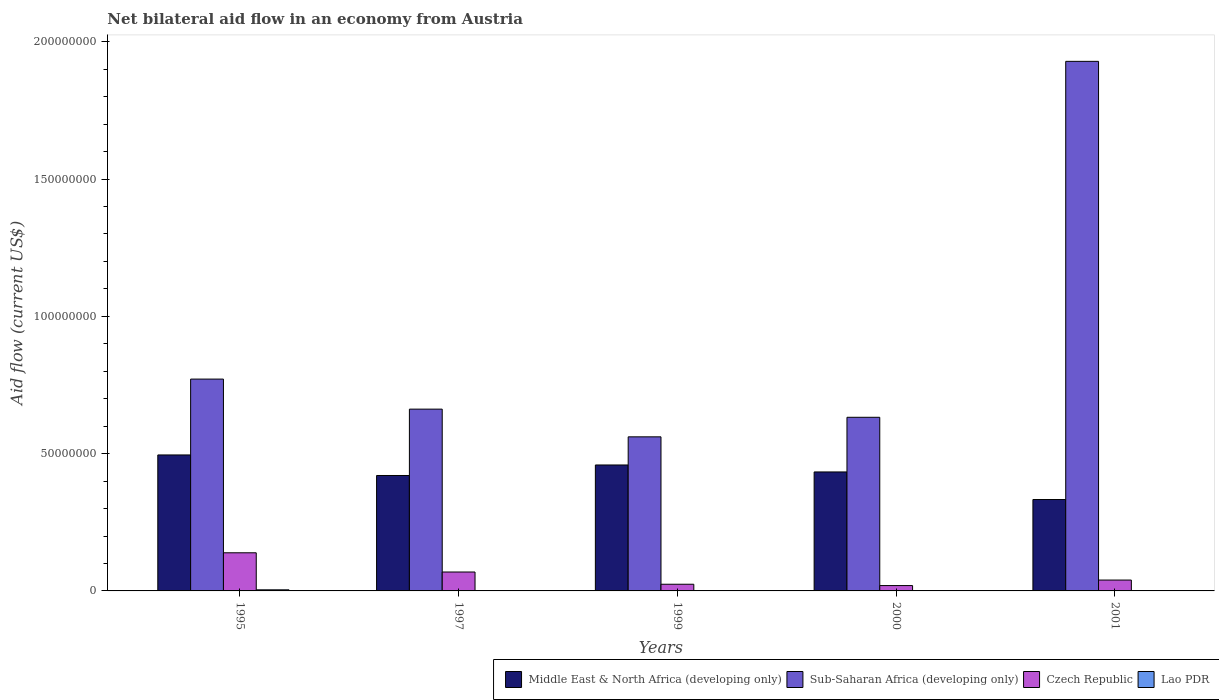How many different coloured bars are there?
Ensure brevity in your answer.  4. How many groups of bars are there?
Ensure brevity in your answer.  5. Are the number of bars per tick equal to the number of legend labels?
Provide a short and direct response. Yes. Are the number of bars on each tick of the X-axis equal?
Offer a terse response. Yes. What is the label of the 2nd group of bars from the left?
Offer a terse response. 1997. In how many cases, is the number of bars for a given year not equal to the number of legend labels?
Make the answer very short. 0. What is the net bilateral aid flow in Lao PDR in 1995?
Offer a terse response. 4.00e+05. Across all years, what is the maximum net bilateral aid flow in Lao PDR?
Offer a terse response. 4.00e+05. Across all years, what is the minimum net bilateral aid flow in Czech Republic?
Provide a succinct answer. 1.95e+06. In which year was the net bilateral aid flow in Czech Republic maximum?
Ensure brevity in your answer.  1995. In which year was the net bilateral aid flow in Czech Republic minimum?
Provide a short and direct response. 2000. What is the total net bilateral aid flow in Sub-Saharan Africa (developing only) in the graph?
Ensure brevity in your answer.  4.56e+08. What is the difference between the net bilateral aid flow in Czech Republic in 1995 and that in 1999?
Your response must be concise. 1.15e+07. What is the difference between the net bilateral aid flow in Middle East & North Africa (developing only) in 2000 and the net bilateral aid flow in Czech Republic in 1997?
Provide a succinct answer. 3.64e+07. What is the average net bilateral aid flow in Czech Republic per year?
Provide a short and direct response. 5.82e+06. In the year 1999, what is the difference between the net bilateral aid flow in Sub-Saharan Africa (developing only) and net bilateral aid flow in Middle East & North Africa (developing only)?
Provide a short and direct response. 1.02e+07. In how many years, is the net bilateral aid flow in Middle East & North Africa (developing only) greater than 130000000 US$?
Offer a terse response. 0. Is the net bilateral aid flow in Sub-Saharan Africa (developing only) in 1997 less than that in 1999?
Provide a short and direct response. No. What is the difference between the highest and the lowest net bilateral aid flow in Middle East & North Africa (developing only)?
Your response must be concise. 1.62e+07. In how many years, is the net bilateral aid flow in Czech Republic greater than the average net bilateral aid flow in Czech Republic taken over all years?
Keep it short and to the point. 2. Is the sum of the net bilateral aid flow in Lao PDR in 1999 and 2001 greater than the maximum net bilateral aid flow in Middle East & North Africa (developing only) across all years?
Provide a succinct answer. No. Is it the case that in every year, the sum of the net bilateral aid flow in Lao PDR and net bilateral aid flow in Sub-Saharan Africa (developing only) is greater than the sum of net bilateral aid flow in Middle East & North Africa (developing only) and net bilateral aid flow in Czech Republic?
Your answer should be compact. No. What does the 2nd bar from the left in 1995 represents?
Provide a short and direct response. Sub-Saharan Africa (developing only). What does the 4th bar from the right in 1997 represents?
Make the answer very short. Middle East & North Africa (developing only). Is it the case that in every year, the sum of the net bilateral aid flow in Lao PDR and net bilateral aid flow in Czech Republic is greater than the net bilateral aid flow in Middle East & North Africa (developing only)?
Give a very brief answer. No. Are all the bars in the graph horizontal?
Offer a very short reply. No. How many years are there in the graph?
Offer a very short reply. 5. What is the difference between two consecutive major ticks on the Y-axis?
Your answer should be compact. 5.00e+07. Are the values on the major ticks of Y-axis written in scientific E-notation?
Your response must be concise. No. Does the graph contain any zero values?
Your answer should be very brief. No. Does the graph contain grids?
Make the answer very short. No. Where does the legend appear in the graph?
Provide a succinct answer. Bottom right. How are the legend labels stacked?
Offer a terse response. Horizontal. What is the title of the graph?
Provide a succinct answer. Net bilateral aid flow in an economy from Austria. What is the label or title of the X-axis?
Ensure brevity in your answer.  Years. What is the label or title of the Y-axis?
Provide a succinct answer. Aid flow (current US$). What is the Aid flow (current US$) of Middle East & North Africa (developing only) in 1995?
Provide a short and direct response. 4.95e+07. What is the Aid flow (current US$) of Sub-Saharan Africa (developing only) in 1995?
Make the answer very short. 7.72e+07. What is the Aid flow (current US$) in Czech Republic in 1995?
Offer a terse response. 1.39e+07. What is the Aid flow (current US$) of Middle East & North Africa (developing only) in 1997?
Give a very brief answer. 4.20e+07. What is the Aid flow (current US$) in Sub-Saharan Africa (developing only) in 1997?
Ensure brevity in your answer.  6.62e+07. What is the Aid flow (current US$) of Czech Republic in 1997?
Keep it short and to the point. 6.89e+06. What is the Aid flow (current US$) in Lao PDR in 1997?
Make the answer very short. 3.00e+04. What is the Aid flow (current US$) of Middle East & North Africa (developing only) in 1999?
Offer a very short reply. 4.59e+07. What is the Aid flow (current US$) in Sub-Saharan Africa (developing only) in 1999?
Offer a very short reply. 5.61e+07. What is the Aid flow (current US$) of Czech Republic in 1999?
Keep it short and to the point. 2.43e+06. What is the Aid flow (current US$) in Middle East & North Africa (developing only) in 2000?
Your answer should be compact. 4.33e+07. What is the Aid flow (current US$) in Sub-Saharan Africa (developing only) in 2000?
Make the answer very short. 6.32e+07. What is the Aid flow (current US$) in Czech Republic in 2000?
Offer a terse response. 1.95e+06. What is the Aid flow (current US$) of Middle East & North Africa (developing only) in 2001?
Ensure brevity in your answer.  3.33e+07. What is the Aid flow (current US$) of Sub-Saharan Africa (developing only) in 2001?
Give a very brief answer. 1.93e+08. What is the Aid flow (current US$) in Czech Republic in 2001?
Provide a short and direct response. 3.96e+06. What is the Aid flow (current US$) in Lao PDR in 2001?
Provide a short and direct response. 4.00e+04. Across all years, what is the maximum Aid flow (current US$) in Middle East & North Africa (developing only)?
Your response must be concise. 4.95e+07. Across all years, what is the maximum Aid flow (current US$) in Sub-Saharan Africa (developing only)?
Provide a succinct answer. 1.93e+08. Across all years, what is the maximum Aid flow (current US$) of Czech Republic?
Offer a very short reply. 1.39e+07. Across all years, what is the minimum Aid flow (current US$) in Middle East & North Africa (developing only)?
Ensure brevity in your answer.  3.33e+07. Across all years, what is the minimum Aid flow (current US$) of Sub-Saharan Africa (developing only)?
Your answer should be compact. 5.61e+07. Across all years, what is the minimum Aid flow (current US$) in Czech Republic?
Ensure brevity in your answer.  1.95e+06. What is the total Aid flow (current US$) in Middle East & North Africa (developing only) in the graph?
Provide a short and direct response. 2.14e+08. What is the total Aid flow (current US$) of Sub-Saharan Africa (developing only) in the graph?
Keep it short and to the point. 4.56e+08. What is the total Aid flow (current US$) of Czech Republic in the graph?
Offer a very short reply. 2.91e+07. What is the total Aid flow (current US$) in Lao PDR in the graph?
Keep it short and to the point. 5.10e+05. What is the difference between the Aid flow (current US$) in Middle East & North Africa (developing only) in 1995 and that in 1997?
Your answer should be compact. 7.48e+06. What is the difference between the Aid flow (current US$) of Sub-Saharan Africa (developing only) in 1995 and that in 1997?
Keep it short and to the point. 1.09e+07. What is the difference between the Aid flow (current US$) in Czech Republic in 1995 and that in 1997?
Give a very brief answer. 7.00e+06. What is the difference between the Aid flow (current US$) of Lao PDR in 1995 and that in 1997?
Provide a short and direct response. 3.70e+05. What is the difference between the Aid flow (current US$) in Middle East & North Africa (developing only) in 1995 and that in 1999?
Provide a short and direct response. 3.65e+06. What is the difference between the Aid flow (current US$) of Sub-Saharan Africa (developing only) in 1995 and that in 1999?
Your answer should be compact. 2.10e+07. What is the difference between the Aid flow (current US$) of Czech Republic in 1995 and that in 1999?
Your answer should be very brief. 1.15e+07. What is the difference between the Aid flow (current US$) of Middle East & North Africa (developing only) in 1995 and that in 2000?
Keep it short and to the point. 6.19e+06. What is the difference between the Aid flow (current US$) in Sub-Saharan Africa (developing only) in 1995 and that in 2000?
Provide a succinct answer. 1.39e+07. What is the difference between the Aid flow (current US$) of Czech Republic in 1995 and that in 2000?
Provide a succinct answer. 1.19e+07. What is the difference between the Aid flow (current US$) of Lao PDR in 1995 and that in 2000?
Keep it short and to the point. 3.70e+05. What is the difference between the Aid flow (current US$) of Middle East & North Africa (developing only) in 1995 and that in 2001?
Ensure brevity in your answer.  1.62e+07. What is the difference between the Aid flow (current US$) of Sub-Saharan Africa (developing only) in 1995 and that in 2001?
Ensure brevity in your answer.  -1.16e+08. What is the difference between the Aid flow (current US$) in Czech Republic in 1995 and that in 2001?
Keep it short and to the point. 9.93e+06. What is the difference between the Aid flow (current US$) of Lao PDR in 1995 and that in 2001?
Keep it short and to the point. 3.60e+05. What is the difference between the Aid flow (current US$) in Middle East & North Africa (developing only) in 1997 and that in 1999?
Offer a very short reply. -3.83e+06. What is the difference between the Aid flow (current US$) of Sub-Saharan Africa (developing only) in 1997 and that in 1999?
Your answer should be very brief. 1.01e+07. What is the difference between the Aid flow (current US$) of Czech Republic in 1997 and that in 1999?
Offer a terse response. 4.46e+06. What is the difference between the Aid flow (current US$) in Lao PDR in 1997 and that in 1999?
Your response must be concise. 2.00e+04. What is the difference between the Aid flow (current US$) in Middle East & North Africa (developing only) in 1997 and that in 2000?
Make the answer very short. -1.29e+06. What is the difference between the Aid flow (current US$) of Sub-Saharan Africa (developing only) in 1997 and that in 2000?
Provide a short and direct response. 2.97e+06. What is the difference between the Aid flow (current US$) of Czech Republic in 1997 and that in 2000?
Keep it short and to the point. 4.94e+06. What is the difference between the Aid flow (current US$) in Middle East & North Africa (developing only) in 1997 and that in 2001?
Give a very brief answer. 8.75e+06. What is the difference between the Aid flow (current US$) in Sub-Saharan Africa (developing only) in 1997 and that in 2001?
Give a very brief answer. -1.27e+08. What is the difference between the Aid flow (current US$) of Czech Republic in 1997 and that in 2001?
Ensure brevity in your answer.  2.93e+06. What is the difference between the Aid flow (current US$) of Middle East & North Africa (developing only) in 1999 and that in 2000?
Your response must be concise. 2.54e+06. What is the difference between the Aid flow (current US$) in Sub-Saharan Africa (developing only) in 1999 and that in 2000?
Your answer should be compact. -7.12e+06. What is the difference between the Aid flow (current US$) in Middle East & North Africa (developing only) in 1999 and that in 2001?
Give a very brief answer. 1.26e+07. What is the difference between the Aid flow (current US$) in Sub-Saharan Africa (developing only) in 1999 and that in 2001?
Offer a terse response. -1.37e+08. What is the difference between the Aid flow (current US$) of Czech Republic in 1999 and that in 2001?
Make the answer very short. -1.53e+06. What is the difference between the Aid flow (current US$) of Lao PDR in 1999 and that in 2001?
Offer a very short reply. -3.00e+04. What is the difference between the Aid flow (current US$) in Middle East & North Africa (developing only) in 2000 and that in 2001?
Provide a succinct answer. 1.00e+07. What is the difference between the Aid flow (current US$) of Sub-Saharan Africa (developing only) in 2000 and that in 2001?
Ensure brevity in your answer.  -1.30e+08. What is the difference between the Aid flow (current US$) of Czech Republic in 2000 and that in 2001?
Give a very brief answer. -2.01e+06. What is the difference between the Aid flow (current US$) of Middle East & North Africa (developing only) in 1995 and the Aid flow (current US$) of Sub-Saharan Africa (developing only) in 1997?
Your response must be concise. -1.67e+07. What is the difference between the Aid flow (current US$) in Middle East & North Africa (developing only) in 1995 and the Aid flow (current US$) in Czech Republic in 1997?
Ensure brevity in your answer.  4.26e+07. What is the difference between the Aid flow (current US$) of Middle East & North Africa (developing only) in 1995 and the Aid flow (current US$) of Lao PDR in 1997?
Ensure brevity in your answer.  4.95e+07. What is the difference between the Aid flow (current US$) of Sub-Saharan Africa (developing only) in 1995 and the Aid flow (current US$) of Czech Republic in 1997?
Your answer should be compact. 7.03e+07. What is the difference between the Aid flow (current US$) of Sub-Saharan Africa (developing only) in 1995 and the Aid flow (current US$) of Lao PDR in 1997?
Provide a succinct answer. 7.71e+07. What is the difference between the Aid flow (current US$) in Czech Republic in 1995 and the Aid flow (current US$) in Lao PDR in 1997?
Make the answer very short. 1.39e+07. What is the difference between the Aid flow (current US$) of Middle East & North Africa (developing only) in 1995 and the Aid flow (current US$) of Sub-Saharan Africa (developing only) in 1999?
Provide a succinct answer. -6.60e+06. What is the difference between the Aid flow (current US$) of Middle East & North Africa (developing only) in 1995 and the Aid flow (current US$) of Czech Republic in 1999?
Ensure brevity in your answer.  4.71e+07. What is the difference between the Aid flow (current US$) of Middle East & North Africa (developing only) in 1995 and the Aid flow (current US$) of Lao PDR in 1999?
Your response must be concise. 4.95e+07. What is the difference between the Aid flow (current US$) of Sub-Saharan Africa (developing only) in 1995 and the Aid flow (current US$) of Czech Republic in 1999?
Offer a terse response. 7.47e+07. What is the difference between the Aid flow (current US$) in Sub-Saharan Africa (developing only) in 1995 and the Aid flow (current US$) in Lao PDR in 1999?
Your answer should be very brief. 7.71e+07. What is the difference between the Aid flow (current US$) of Czech Republic in 1995 and the Aid flow (current US$) of Lao PDR in 1999?
Offer a very short reply. 1.39e+07. What is the difference between the Aid flow (current US$) in Middle East & North Africa (developing only) in 1995 and the Aid flow (current US$) in Sub-Saharan Africa (developing only) in 2000?
Offer a terse response. -1.37e+07. What is the difference between the Aid flow (current US$) of Middle East & North Africa (developing only) in 1995 and the Aid flow (current US$) of Czech Republic in 2000?
Keep it short and to the point. 4.76e+07. What is the difference between the Aid flow (current US$) of Middle East & North Africa (developing only) in 1995 and the Aid flow (current US$) of Lao PDR in 2000?
Ensure brevity in your answer.  4.95e+07. What is the difference between the Aid flow (current US$) of Sub-Saharan Africa (developing only) in 1995 and the Aid flow (current US$) of Czech Republic in 2000?
Your answer should be compact. 7.52e+07. What is the difference between the Aid flow (current US$) of Sub-Saharan Africa (developing only) in 1995 and the Aid flow (current US$) of Lao PDR in 2000?
Provide a succinct answer. 7.71e+07. What is the difference between the Aid flow (current US$) of Czech Republic in 1995 and the Aid flow (current US$) of Lao PDR in 2000?
Your response must be concise. 1.39e+07. What is the difference between the Aid flow (current US$) in Middle East & North Africa (developing only) in 1995 and the Aid flow (current US$) in Sub-Saharan Africa (developing only) in 2001?
Make the answer very short. -1.43e+08. What is the difference between the Aid flow (current US$) of Middle East & North Africa (developing only) in 1995 and the Aid flow (current US$) of Czech Republic in 2001?
Offer a very short reply. 4.56e+07. What is the difference between the Aid flow (current US$) of Middle East & North Africa (developing only) in 1995 and the Aid flow (current US$) of Lao PDR in 2001?
Your answer should be compact. 4.95e+07. What is the difference between the Aid flow (current US$) in Sub-Saharan Africa (developing only) in 1995 and the Aid flow (current US$) in Czech Republic in 2001?
Ensure brevity in your answer.  7.32e+07. What is the difference between the Aid flow (current US$) of Sub-Saharan Africa (developing only) in 1995 and the Aid flow (current US$) of Lao PDR in 2001?
Your answer should be very brief. 7.71e+07. What is the difference between the Aid flow (current US$) of Czech Republic in 1995 and the Aid flow (current US$) of Lao PDR in 2001?
Your answer should be compact. 1.38e+07. What is the difference between the Aid flow (current US$) of Middle East & North Africa (developing only) in 1997 and the Aid flow (current US$) of Sub-Saharan Africa (developing only) in 1999?
Keep it short and to the point. -1.41e+07. What is the difference between the Aid flow (current US$) in Middle East & North Africa (developing only) in 1997 and the Aid flow (current US$) in Czech Republic in 1999?
Offer a terse response. 3.96e+07. What is the difference between the Aid flow (current US$) in Middle East & North Africa (developing only) in 1997 and the Aid flow (current US$) in Lao PDR in 1999?
Your answer should be very brief. 4.20e+07. What is the difference between the Aid flow (current US$) of Sub-Saharan Africa (developing only) in 1997 and the Aid flow (current US$) of Czech Republic in 1999?
Keep it short and to the point. 6.38e+07. What is the difference between the Aid flow (current US$) in Sub-Saharan Africa (developing only) in 1997 and the Aid flow (current US$) in Lao PDR in 1999?
Your answer should be compact. 6.62e+07. What is the difference between the Aid flow (current US$) in Czech Republic in 1997 and the Aid flow (current US$) in Lao PDR in 1999?
Provide a short and direct response. 6.88e+06. What is the difference between the Aid flow (current US$) of Middle East & North Africa (developing only) in 1997 and the Aid flow (current US$) of Sub-Saharan Africa (developing only) in 2000?
Provide a succinct answer. -2.12e+07. What is the difference between the Aid flow (current US$) of Middle East & North Africa (developing only) in 1997 and the Aid flow (current US$) of Czech Republic in 2000?
Your answer should be compact. 4.01e+07. What is the difference between the Aid flow (current US$) of Middle East & North Africa (developing only) in 1997 and the Aid flow (current US$) of Lao PDR in 2000?
Your answer should be very brief. 4.20e+07. What is the difference between the Aid flow (current US$) in Sub-Saharan Africa (developing only) in 1997 and the Aid flow (current US$) in Czech Republic in 2000?
Ensure brevity in your answer.  6.43e+07. What is the difference between the Aid flow (current US$) of Sub-Saharan Africa (developing only) in 1997 and the Aid flow (current US$) of Lao PDR in 2000?
Offer a terse response. 6.62e+07. What is the difference between the Aid flow (current US$) in Czech Republic in 1997 and the Aid flow (current US$) in Lao PDR in 2000?
Your answer should be very brief. 6.86e+06. What is the difference between the Aid flow (current US$) in Middle East & North Africa (developing only) in 1997 and the Aid flow (current US$) in Sub-Saharan Africa (developing only) in 2001?
Keep it short and to the point. -1.51e+08. What is the difference between the Aid flow (current US$) in Middle East & North Africa (developing only) in 1997 and the Aid flow (current US$) in Czech Republic in 2001?
Offer a very short reply. 3.81e+07. What is the difference between the Aid flow (current US$) of Middle East & North Africa (developing only) in 1997 and the Aid flow (current US$) of Lao PDR in 2001?
Make the answer very short. 4.20e+07. What is the difference between the Aid flow (current US$) in Sub-Saharan Africa (developing only) in 1997 and the Aid flow (current US$) in Czech Republic in 2001?
Ensure brevity in your answer.  6.22e+07. What is the difference between the Aid flow (current US$) in Sub-Saharan Africa (developing only) in 1997 and the Aid flow (current US$) in Lao PDR in 2001?
Offer a very short reply. 6.62e+07. What is the difference between the Aid flow (current US$) of Czech Republic in 1997 and the Aid flow (current US$) of Lao PDR in 2001?
Give a very brief answer. 6.85e+06. What is the difference between the Aid flow (current US$) in Middle East & North Africa (developing only) in 1999 and the Aid flow (current US$) in Sub-Saharan Africa (developing only) in 2000?
Your answer should be very brief. -1.74e+07. What is the difference between the Aid flow (current US$) of Middle East & North Africa (developing only) in 1999 and the Aid flow (current US$) of Czech Republic in 2000?
Make the answer very short. 4.39e+07. What is the difference between the Aid flow (current US$) of Middle East & North Africa (developing only) in 1999 and the Aid flow (current US$) of Lao PDR in 2000?
Give a very brief answer. 4.58e+07. What is the difference between the Aid flow (current US$) of Sub-Saharan Africa (developing only) in 1999 and the Aid flow (current US$) of Czech Republic in 2000?
Your answer should be compact. 5.42e+07. What is the difference between the Aid flow (current US$) in Sub-Saharan Africa (developing only) in 1999 and the Aid flow (current US$) in Lao PDR in 2000?
Make the answer very short. 5.61e+07. What is the difference between the Aid flow (current US$) in Czech Republic in 1999 and the Aid flow (current US$) in Lao PDR in 2000?
Provide a succinct answer. 2.40e+06. What is the difference between the Aid flow (current US$) in Middle East & North Africa (developing only) in 1999 and the Aid flow (current US$) in Sub-Saharan Africa (developing only) in 2001?
Keep it short and to the point. -1.47e+08. What is the difference between the Aid flow (current US$) of Middle East & North Africa (developing only) in 1999 and the Aid flow (current US$) of Czech Republic in 2001?
Keep it short and to the point. 4.19e+07. What is the difference between the Aid flow (current US$) in Middle East & North Africa (developing only) in 1999 and the Aid flow (current US$) in Lao PDR in 2001?
Ensure brevity in your answer.  4.58e+07. What is the difference between the Aid flow (current US$) in Sub-Saharan Africa (developing only) in 1999 and the Aid flow (current US$) in Czech Republic in 2001?
Your response must be concise. 5.22e+07. What is the difference between the Aid flow (current US$) in Sub-Saharan Africa (developing only) in 1999 and the Aid flow (current US$) in Lao PDR in 2001?
Your response must be concise. 5.61e+07. What is the difference between the Aid flow (current US$) of Czech Republic in 1999 and the Aid flow (current US$) of Lao PDR in 2001?
Offer a very short reply. 2.39e+06. What is the difference between the Aid flow (current US$) in Middle East & North Africa (developing only) in 2000 and the Aid flow (current US$) in Sub-Saharan Africa (developing only) in 2001?
Make the answer very short. -1.50e+08. What is the difference between the Aid flow (current US$) of Middle East & North Africa (developing only) in 2000 and the Aid flow (current US$) of Czech Republic in 2001?
Your answer should be compact. 3.94e+07. What is the difference between the Aid flow (current US$) in Middle East & North Africa (developing only) in 2000 and the Aid flow (current US$) in Lao PDR in 2001?
Keep it short and to the point. 4.33e+07. What is the difference between the Aid flow (current US$) of Sub-Saharan Africa (developing only) in 2000 and the Aid flow (current US$) of Czech Republic in 2001?
Provide a succinct answer. 5.93e+07. What is the difference between the Aid flow (current US$) of Sub-Saharan Africa (developing only) in 2000 and the Aid flow (current US$) of Lao PDR in 2001?
Provide a succinct answer. 6.32e+07. What is the difference between the Aid flow (current US$) in Czech Republic in 2000 and the Aid flow (current US$) in Lao PDR in 2001?
Make the answer very short. 1.91e+06. What is the average Aid flow (current US$) of Middle East & North Africa (developing only) per year?
Keep it short and to the point. 4.28e+07. What is the average Aid flow (current US$) of Sub-Saharan Africa (developing only) per year?
Offer a terse response. 9.11e+07. What is the average Aid flow (current US$) of Czech Republic per year?
Offer a very short reply. 5.82e+06. What is the average Aid flow (current US$) in Lao PDR per year?
Ensure brevity in your answer.  1.02e+05. In the year 1995, what is the difference between the Aid flow (current US$) of Middle East & North Africa (developing only) and Aid flow (current US$) of Sub-Saharan Africa (developing only)?
Give a very brief answer. -2.76e+07. In the year 1995, what is the difference between the Aid flow (current US$) in Middle East & North Africa (developing only) and Aid flow (current US$) in Czech Republic?
Offer a terse response. 3.56e+07. In the year 1995, what is the difference between the Aid flow (current US$) in Middle East & North Africa (developing only) and Aid flow (current US$) in Lao PDR?
Provide a short and direct response. 4.91e+07. In the year 1995, what is the difference between the Aid flow (current US$) in Sub-Saharan Africa (developing only) and Aid flow (current US$) in Czech Republic?
Provide a short and direct response. 6.33e+07. In the year 1995, what is the difference between the Aid flow (current US$) of Sub-Saharan Africa (developing only) and Aid flow (current US$) of Lao PDR?
Your answer should be very brief. 7.68e+07. In the year 1995, what is the difference between the Aid flow (current US$) of Czech Republic and Aid flow (current US$) of Lao PDR?
Give a very brief answer. 1.35e+07. In the year 1997, what is the difference between the Aid flow (current US$) in Middle East & North Africa (developing only) and Aid flow (current US$) in Sub-Saharan Africa (developing only)?
Your response must be concise. -2.42e+07. In the year 1997, what is the difference between the Aid flow (current US$) in Middle East & North Africa (developing only) and Aid flow (current US$) in Czech Republic?
Offer a very short reply. 3.52e+07. In the year 1997, what is the difference between the Aid flow (current US$) in Middle East & North Africa (developing only) and Aid flow (current US$) in Lao PDR?
Keep it short and to the point. 4.20e+07. In the year 1997, what is the difference between the Aid flow (current US$) of Sub-Saharan Africa (developing only) and Aid flow (current US$) of Czech Republic?
Offer a very short reply. 5.93e+07. In the year 1997, what is the difference between the Aid flow (current US$) of Sub-Saharan Africa (developing only) and Aid flow (current US$) of Lao PDR?
Give a very brief answer. 6.62e+07. In the year 1997, what is the difference between the Aid flow (current US$) in Czech Republic and Aid flow (current US$) in Lao PDR?
Provide a short and direct response. 6.86e+06. In the year 1999, what is the difference between the Aid flow (current US$) of Middle East & North Africa (developing only) and Aid flow (current US$) of Sub-Saharan Africa (developing only)?
Your answer should be compact. -1.02e+07. In the year 1999, what is the difference between the Aid flow (current US$) in Middle East & North Africa (developing only) and Aid flow (current US$) in Czech Republic?
Ensure brevity in your answer.  4.34e+07. In the year 1999, what is the difference between the Aid flow (current US$) of Middle East & North Africa (developing only) and Aid flow (current US$) of Lao PDR?
Provide a succinct answer. 4.59e+07. In the year 1999, what is the difference between the Aid flow (current US$) of Sub-Saharan Africa (developing only) and Aid flow (current US$) of Czech Republic?
Keep it short and to the point. 5.37e+07. In the year 1999, what is the difference between the Aid flow (current US$) in Sub-Saharan Africa (developing only) and Aid flow (current US$) in Lao PDR?
Your answer should be compact. 5.61e+07. In the year 1999, what is the difference between the Aid flow (current US$) in Czech Republic and Aid flow (current US$) in Lao PDR?
Provide a short and direct response. 2.42e+06. In the year 2000, what is the difference between the Aid flow (current US$) in Middle East & North Africa (developing only) and Aid flow (current US$) in Sub-Saharan Africa (developing only)?
Provide a short and direct response. -1.99e+07. In the year 2000, what is the difference between the Aid flow (current US$) of Middle East & North Africa (developing only) and Aid flow (current US$) of Czech Republic?
Keep it short and to the point. 4.14e+07. In the year 2000, what is the difference between the Aid flow (current US$) in Middle East & North Africa (developing only) and Aid flow (current US$) in Lao PDR?
Give a very brief answer. 4.33e+07. In the year 2000, what is the difference between the Aid flow (current US$) in Sub-Saharan Africa (developing only) and Aid flow (current US$) in Czech Republic?
Your answer should be compact. 6.13e+07. In the year 2000, what is the difference between the Aid flow (current US$) in Sub-Saharan Africa (developing only) and Aid flow (current US$) in Lao PDR?
Keep it short and to the point. 6.32e+07. In the year 2000, what is the difference between the Aid flow (current US$) of Czech Republic and Aid flow (current US$) of Lao PDR?
Make the answer very short. 1.92e+06. In the year 2001, what is the difference between the Aid flow (current US$) in Middle East & North Africa (developing only) and Aid flow (current US$) in Sub-Saharan Africa (developing only)?
Make the answer very short. -1.60e+08. In the year 2001, what is the difference between the Aid flow (current US$) in Middle East & North Africa (developing only) and Aid flow (current US$) in Czech Republic?
Your answer should be compact. 2.93e+07. In the year 2001, what is the difference between the Aid flow (current US$) in Middle East & North Africa (developing only) and Aid flow (current US$) in Lao PDR?
Your answer should be very brief. 3.32e+07. In the year 2001, what is the difference between the Aid flow (current US$) of Sub-Saharan Africa (developing only) and Aid flow (current US$) of Czech Republic?
Keep it short and to the point. 1.89e+08. In the year 2001, what is the difference between the Aid flow (current US$) of Sub-Saharan Africa (developing only) and Aid flow (current US$) of Lao PDR?
Give a very brief answer. 1.93e+08. In the year 2001, what is the difference between the Aid flow (current US$) in Czech Republic and Aid flow (current US$) in Lao PDR?
Provide a succinct answer. 3.92e+06. What is the ratio of the Aid flow (current US$) of Middle East & North Africa (developing only) in 1995 to that in 1997?
Give a very brief answer. 1.18. What is the ratio of the Aid flow (current US$) in Sub-Saharan Africa (developing only) in 1995 to that in 1997?
Offer a terse response. 1.17. What is the ratio of the Aid flow (current US$) of Czech Republic in 1995 to that in 1997?
Ensure brevity in your answer.  2.02. What is the ratio of the Aid flow (current US$) in Lao PDR in 1995 to that in 1997?
Offer a terse response. 13.33. What is the ratio of the Aid flow (current US$) of Middle East & North Africa (developing only) in 1995 to that in 1999?
Provide a succinct answer. 1.08. What is the ratio of the Aid flow (current US$) in Sub-Saharan Africa (developing only) in 1995 to that in 1999?
Provide a succinct answer. 1.37. What is the ratio of the Aid flow (current US$) in Czech Republic in 1995 to that in 1999?
Ensure brevity in your answer.  5.72. What is the ratio of the Aid flow (current US$) of Lao PDR in 1995 to that in 1999?
Your response must be concise. 40. What is the ratio of the Aid flow (current US$) of Middle East & North Africa (developing only) in 1995 to that in 2000?
Offer a very short reply. 1.14. What is the ratio of the Aid flow (current US$) of Sub-Saharan Africa (developing only) in 1995 to that in 2000?
Make the answer very short. 1.22. What is the ratio of the Aid flow (current US$) of Czech Republic in 1995 to that in 2000?
Ensure brevity in your answer.  7.12. What is the ratio of the Aid flow (current US$) of Lao PDR in 1995 to that in 2000?
Your answer should be compact. 13.33. What is the ratio of the Aid flow (current US$) of Middle East & North Africa (developing only) in 1995 to that in 2001?
Provide a succinct answer. 1.49. What is the ratio of the Aid flow (current US$) of Czech Republic in 1995 to that in 2001?
Keep it short and to the point. 3.51. What is the ratio of the Aid flow (current US$) of Middle East & North Africa (developing only) in 1997 to that in 1999?
Provide a succinct answer. 0.92. What is the ratio of the Aid flow (current US$) in Sub-Saharan Africa (developing only) in 1997 to that in 1999?
Ensure brevity in your answer.  1.18. What is the ratio of the Aid flow (current US$) in Czech Republic in 1997 to that in 1999?
Your answer should be very brief. 2.84. What is the ratio of the Aid flow (current US$) in Lao PDR in 1997 to that in 1999?
Offer a terse response. 3. What is the ratio of the Aid flow (current US$) of Middle East & North Africa (developing only) in 1997 to that in 2000?
Your answer should be compact. 0.97. What is the ratio of the Aid flow (current US$) in Sub-Saharan Africa (developing only) in 1997 to that in 2000?
Your response must be concise. 1.05. What is the ratio of the Aid flow (current US$) of Czech Republic in 1997 to that in 2000?
Offer a terse response. 3.53. What is the ratio of the Aid flow (current US$) of Lao PDR in 1997 to that in 2000?
Keep it short and to the point. 1. What is the ratio of the Aid flow (current US$) of Middle East & North Africa (developing only) in 1997 to that in 2001?
Keep it short and to the point. 1.26. What is the ratio of the Aid flow (current US$) in Sub-Saharan Africa (developing only) in 1997 to that in 2001?
Ensure brevity in your answer.  0.34. What is the ratio of the Aid flow (current US$) in Czech Republic in 1997 to that in 2001?
Make the answer very short. 1.74. What is the ratio of the Aid flow (current US$) of Lao PDR in 1997 to that in 2001?
Your answer should be compact. 0.75. What is the ratio of the Aid flow (current US$) in Middle East & North Africa (developing only) in 1999 to that in 2000?
Your response must be concise. 1.06. What is the ratio of the Aid flow (current US$) in Sub-Saharan Africa (developing only) in 1999 to that in 2000?
Give a very brief answer. 0.89. What is the ratio of the Aid flow (current US$) in Czech Republic in 1999 to that in 2000?
Provide a succinct answer. 1.25. What is the ratio of the Aid flow (current US$) of Lao PDR in 1999 to that in 2000?
Your answer should be compact. 0.33. What is the ratio of the Aid flow (current US$) in Middle East & North Africa (developing only) in 1999 to that in 2001?
Your response must be concise. 1.38. What is the ratio of the Aid flow (current US$) of Sub-Saharan Africa (developing only) in 1999 to that in 2001?
Your answer should be compact. 0.29. What is the ratio of the Aid flow (current US$) in Czech Republic in 1999 to that in 2001?
Give a very brief answer. 0.61. What is the ratio of the Aid flow (current US$) in Lao PDR in 1999 to that in 2001?
Your answer should be compact. 0.25. What is the ratio of the Aid flow (current US$) of Middle East & North Africa (developing only) in 2000 to that in 2001?
Keep it short and to the point. 1.3. What is the ratio of the Aid flow (current US$) in Sub-Saharan Africa (developing only) in 2000 to that in 2001?
Ensure brevity in your answer.  0.33. What is the ratio of the Aid flow (current US$) in Czech Republic in 2000 to that in 2001?
Your response must be concise. 0.49. What is the ratio of the Aid flow (current US$) in Lao PDR in 2000 to that in 2001?
Keep it short and to the point. 0.75. What is the difference between the highest and the second highest Aid flow (current US$) of Middle East & North Africa (developing only)?
Keep it short and to the point. 3.65e+06. What is the difference between the highest and the second highest Aid flow (current US$) in Sub-Saharan Africa (developing only)?
Offer a terse response. 1.16e+08. What is the difference between the highest and the second highest Aid flow (current US$) in Lao PDR?
Ensure brevity in your answer.  3.60e+05. What is the difference between the highest and the lowest Aid flow (current US$) in Middle East & North Africa (developing only)?
Make the answer very short. 1.62e+07. What is the difference between the highest and the lowest Aid flow (current US$) in Sub-Saharan Africa (developing only)?
Ensure brevity in your answer.  1.37e+08. What is the difference between the highest and the lowest Aid flow (current US$) of Czech Republic?
Make the answer very short. 1.19e+07. What is the difference between the highest and the lowest Aid flow (current US$) of Lao PDR?
Provide a succinct answer. 3.90e+05. 